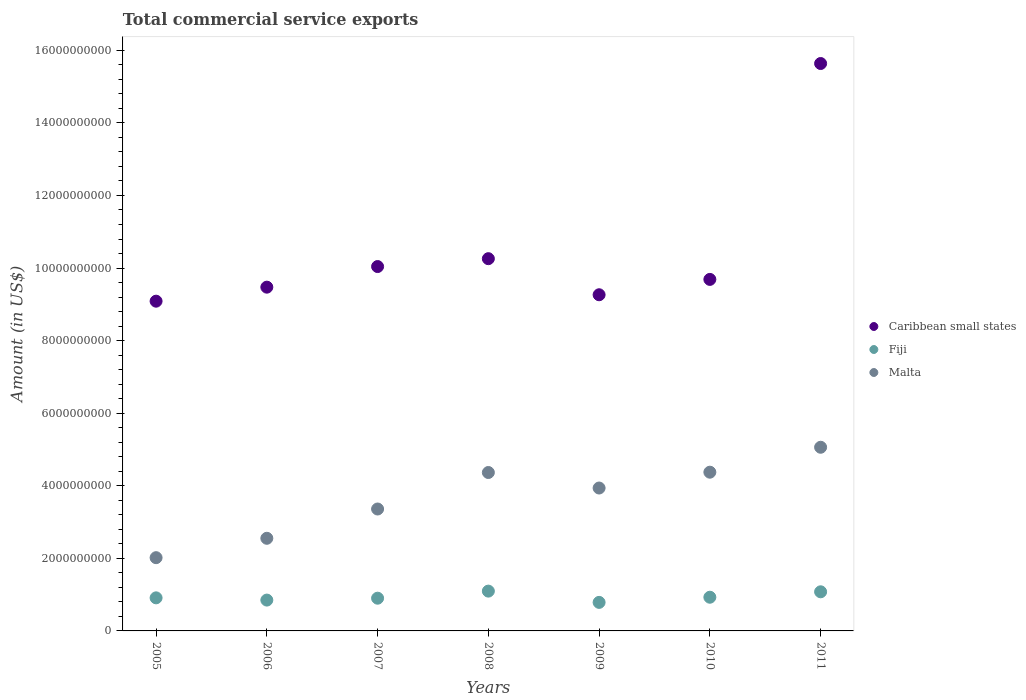What is the total commercial service exports in Caribbean small states in 2008?
Your response must be concise. 1.03e+1. Across all years, what is the maximum total commercial service exports in Caribbean small states?
Provide a succinct answer. 1.56e+1. Across all years, what is the minimum total commercial service exports in Malta?
Keep it short and to the point. 2.02e+09. In which year was the total commercial service exports in Malta maximum?
Provide a short and direct response. 2011. In which year was the total commercial service exports in Malta minimum?
Keep it short and to the point. 2005. What is the total total commercial service exports in Malta in the graph?
Your answer should be compact. 2.57e+1. What is the difference between the total commercial service exports in Caribbean small states in 2008 and that in 2009?
Provide a succinct answer. 9.94e+08. What is the difference between the total commercial service exports in Malta in 2011 and the total commercial service exports in Caribbean small states in 2009?
Your response must be concise. -4.20e+09. What is the average total commercial service exports in Fiji per year?
Ensure brevity in your answer.  9.36e+08. In the year 2008, what is the difference between the total commercial service exports in Malta and total commercial service exports in Fiji?
Give a very brief answer. 3.27e+09. In how many years, is the total commercial service exports in Fiji greater than 12400000000 US$?
Offer a terse response. 0. What is the ratio of the total commercial service exports in Caribbean small states in 2006 to that in 2007?
Your response must be concise. 0.94. Is the total commercial service exports in Caribbean small states in 2006 less than that in 2008?
Your response must be concise. Yes. Is the difference between the total commercial service exports in Malta in 2008 and 2010 greater than the difference between the total commercial service exports in Fiji in 2008 and 2010?
Offer a terse response. No. What is the difference between the highest and the second highest total commercial service exports in Malta?
Your answer should be very brief. 6.87e+08. What is the difference between the highest and the lowest total commercial service exports in Fiji?
Give a very brief answer. 3.11e+08. In how many years, is the total commercial service exports in Caribbean small states greater than the average total commercial service exports in Caribbean small states taken over all years?
Your answer should be compact. 1. Is the sum of the total commercial service exports in Fiji in 2007 and 2008 greater than the maximum total commercial service exports in Caribbean small states across all years?
Your answer should be very brief. No. Is it the case that in every year, the sum of the total commercial service exports in Fiji and total commercial service exports in Caribbean small states  is greater than the total commercial service exports in Malta?
Provide a succinct answer. Yes. Does the total commercial service exports in Fiji monotonically increase over the years?
Your answer should be very brief. No. Is the total commercial service exports in Caribbean small states strictly greater than the total commercial service exports in Fiji over the years?
Make the answer very short. Yes. Are the values on the major ticks of Y-axis written in scientific E-notation?
Offer a terse response. No. Does the graph contain grids?
Make the answer very short. No. Where does the legend appear in the graph?
Ensure brevity in your answer.  Center right. How many legend labels are there?
Make the answer very short. 3. What is the title of the graph?
Give a very brief answer. Total commercial service exports. What is the label or title of the X-axis?
Make the answer very short. Years. What is the label or title of the Y-axis?
Your answer should be compact. Amount (in US$). What is the Amount (in US$) of Caribbean small states in 2005?
Ensure brevity in your answer.  9.09e+09. What is the Amount (in US$) in Fiji in 2005?
Your answer should be very brief. 9.11e+08. What is the Amount (in US$) of Malta in 2005?
Make the answer very short. 2.02e+09. What is the Amount (in US$) of Caribbean small states in 2006?
Offer a very short reply. 9.47e+09. What is the Amount (in US$) of Fiji in 2006?
Your response must be concise. 8.50e+08. What is the Amount (in US$) of Malta in 2006?
Offer a very short reply. 2.55e+09. What is the Amount (in US$) in Caribbean small states in 2007?
Provide a succinct answer. 1.00e+1. What is the Amount (in US$) in Fiji in 2007?
Give a very brief answer. 9.02e+08. What is the Amount (in US$) in Malta in 2007?
Offer a terse response. 3.36e+09. What is the Amount (in US$) in Caribbean small states in 2008?
Ensure brevity in your answer.  1.03e+1. What is the Amount (in US$) in Fiji in 2008?
Make the answer very short. 1.10e+09. What is the Amount (in US$) of Malta in 2008?
Make the answer very short. 4.37e+09. What is the Amount (in US$) of Caribbean small states in 2009?
Make the answer very short. 9.26e+09. What is the Amount (in US$) of Fiji in 2009?
Offer a terse response. 7.86e+08. What is the Amount (in US$) in Malta in 2009?
Keep it short and to the point. 3.94e+09. What is the Amount (in US$) in Caribbean small states in 2010?
Your answer should be compact. 9.69e+09. What is the Amount (in US$) of Fiji in 2010?
Give a very brief answer. 9.28e+08. What is the Amount (in US$) in Malta in 2010?
Make the answer very short. 4.37e+09. What is the Amount (in US$) in Caribbean small states in 2011?
Your answer should be very brief. 1.56e+1. What is the Amount (in US$) of Fiji in 2011?
Offer a terse response. 1.08e+09. What is the Amount (in US$) of Malta in 2011?
Provide a succinct answer. 5.06e+09. Across all years, what is the maximum Amount (in US$) of Caribbean small states?
Provide a short and direct response. 1.56e+1. Across all years, what is the maximum Amount (in US$) in Fiji?
Your response must be concise. 1.10e+09. Across all years, what is the maximum Amount (in US$) in Malta?
Provide a short and direct response. 5.06e+09. Across all years, what is the minimum Amount (in US$) of Caribbean small states?
Provide a succinct answer. 9.09e+09. Across all years, what is the minimum Amount (in US$) in Fiji?
Your response must be concise. 7.86e+08. Across all years, what is the minimum Amount (in US$) of Malta?
Give a very brief answer. 2.02e+09. What is the total Amount (in US$) in Caribbean small states in the graph?
Offer a very short reply. 7.34e+1. What is the total Amount (in US$) in Fiji in the graph?
Keep it short and to the point. 6.55e+09. What is the total Amount (in US$) in Malta in the graph?
Your answer should be compact. 2.57e+1. What is the difference between the Amount (in US$) of Caribbean small states in 2005 and that in 2006?
Your response must be concise. -3.86e+08. What is the difference between the Amount (in US$) of Fiji in 2005 and that in 2006?
Ensure brevity in your answer.  6.16e+07. What is the difference between the Amount (in US$) in Malta in 2005 and that in 2006?
Provide a succinct answer. -5.34e+08. What is the difference between the Amount (in US$) of Caribbean small states in 2005 and that in 2007?
Your answer should be compact. -9.54e+08. What is the difference between the Amount (in US$) of Fiji in 2005 and that in 2007?
Provide a short and direct response. 9.77e+06. What is the difference between the Amount (in US$) of Malta in 2005 and that in 2007?
Keep it short and to the point. -1.34e+09. What is the difference between the Amount (in US$) in Caribbean small states in 2005 and that in 2008?
Ensure brevity in your answer.  -1.17e+09. What is the difference between the Amount (in US$) in Fiji in 2005 and that in 2008?
Give a very brief answer. -1.85e+08. What is the difference between the Amount (in US$) of Malta in 2005 and that in 2008?
Provide a succinct answer. -2.35e+09. What is the difference between the Amount (in US$) in Caribbean small states in 2005 and that in 2009?
Provide a succinct answer. -1.77e+08. What is the difference between the Amount (in US$) in Fiji in 2005 and that in 2009?
Offer a terse response. 1.25e+08. What is the difference between the Amount (in US$) in Malta in 2005 and that in 2009?
Give a very brief answer. -1.92e+09. What is the difference between the Amount (in US$) of Caribbean small states in 2005 and that in 2010?
Offer a very short reply. -6.00e+08. What is the difference between the Amount (in US$) of Fiji in 2005 and that in 2010?
Provide a succinct answer. -1.69e+07. What is the difference between the Amount (in US$) in Malta in 2005 and that in 2010?
Give a very brief answer. -2.36e+09. What is the difference between the Amount (in US$) of Caribbean small states in 2005 and that in 2011?
Offer a terse response. -6.55e+09. What is the difference between the Amount (in US$) of Fiji in 2005 and that in 2011?
Your answer should be compact. -1.66e+08. What is the difference between the Amount (in US$) of Malta in 2005 and that in 2011?
Make the answer very short. -3.04e+09. What is the difference between the Amount (in US$) of Caribbean small states in 2006 and that in 2007?
Ensure brevity in your answer.  -5.68e+08. What is the difference between the Amount (in US$) of Fiji in 2006 and that in 2007?
Provide a short and direct response. -5.18e+07. What is the difference between the Amount (in US$) in Malta in 2006 and that in 2007?
Offer a terse response. -8.07e+08. What is the difference between the Amount (in US$) of Caribbean small states in 2006 and that in 2008?
Ensure brevity in your answer.  -7.85e+08. What is the difference between the Amount (in US$) in Fiji in 2006 and that in 2008?
Your answer should be compact. -2.47e+08. What is the difference between the Amount (in US$) in Malta in 2006 and that in 2008?
Your response must be concise. -1.81e+09. What is the difference between the Amount (in US$) in Caribbean small states in 2006 and that in 2009?
Give a very brief answer. 2.09e+08. What is the difference between the Amount (in US$) of Fiji in 2006 and that in 2009?
Your answer should be compact. 6.36e+07. What is the difference between the Amount (in US$) of Malta in 2006 and that in 2009?
Your answer should be very brief. -1.39e+09. What is the difference between the Amount (in US$) of Caribbean small states in 2006 and that in 2010?
Your answer should be very brief. -2.14e+08. What is the difference between the Amount (in US$) of Fiji in 2006 and that in 2010?
Make the answer very short. -7.85e+07. What is the difference between the Amount (in US$) in Malta in 2006 and that in 2010?
Your answer should be compact. -1.82e+09. What is the difference between the Amount (in US$) in Caribbean small states in 2006 and that in 2011?
Give a very brief answer. -6.16e+09. What is the difference between the Amount (in US$) of Fiji in 2006 and that in 2011?
Your response must be concise. -2.28e+08. What is the difference between the Amount (in US$) in Malta in 2006 and that in 2011?
Offer a very short reply. -2.51e+09. What is the difference between the Amount (in US$) of Caribbean small states in 2007 and that in 2008?
Your response must be concise. -2.17e+08. What is the difference between the Amount (in US$) of Fiji in 2007 and that in 2008?
Provide a succinct answer. -1.95e+08. What is the difference between the Amount (in US$) of Malta in 2007 and that in 2008?
Your answer should be very brief. -1.01e+09. What is the difference between the Amount (in US$) in Caribbean small states in 2007 and that in 2009?
Provide a succinct answer. 7.77e+08. What is the difference between the Amount (in US$) of Fiji in 2007 and that in 2009?
Offer a terse response. 1.15e+08. What is the difference between the Amount (in US$) in Malta in 2007 and that in 2009?
Keep it short and to the point. -5.78e+08. What is the difference between the Amount (in US$) of Caribbean small states in 2007 and that in 2010?
Your answer should be very brief. 3.54e+08. What is the difference between the Amount (in US$) in Fiji in 2007 and that in 2010?
Your answer should be very brief. -2.67e+07. What is the difference between the Amount (in US$) in Malta in 2007 and that in 2010?
Your response must be concise. -1.01e+09. What is the difference between the Amount (in US$) of Caribbean small states in 2007 and that in 2011?
Offer a very short reply. -5.60e+09. What is the difference between the Amount (in US$) of Fiji in 2007 and that in 2011?
Offer a very short reply. -1.76e+08. What is the difference between the Amount (in US$) of Malta in 2007 and that in 2011?
Make the answer very short. -1.70e+09. What is the difference between the Amount (in US$) in Caribbean small states in 2008 and that in 2009?
Offer a very short reply. 9.94e+08. What is the difference between the Amount (in US$) of Fiji in 2008 and that in 2009?
Provide a short and direct response. 3.11e+08. What is the difference between the Amount (in US$) of Malta in 2008 and that in 2009?
Provide a succinct answer. 4.28e+08. What is the difference between the Amount (in US$) of Caribbean small states in 2008 and that in 2010?
Your answer should be very brief. 5.71e+08. What is the difference between the Amount (in US$) in Fiji in 2008 and that in 2010?
Your answer should be very brief. 1.68e+08. What is the difference between the Amount (in US$) in Malta in 2008 and that in 2010?
Your answer should be very brief. -8.65e+06. What is the difference between the Amount (in US$) in Caribbean small states in 2008 and that in 2011?
Keep it short and to the point. -5.38e+09. What is the difference between the Amount (in US$) of Fiji in 2008 and that in 2011?
Your answer should be very brief. 1.89e+07. What is the difference between the Amount (in US$) in Malta in 2008 and that in 2011?
Your answer should be compact. -6.96e+08. What is the difference between the Amount (in US$) in Caribbean small states in 2009 and that in 2010?
Your answer should be very brief. -4.23e+08. What is the difference between the Amount (in US$) of Fiji in 2009 and that in 2010?
Provide a short and direct response. -1.42e+08. What is the difference between the Amount (in US$) in Malta in 2009 and that in 2010?
Make the answer very short. -4.36e+08. What is the difference between the Amount (in US$) in Caribbean small states in 2009 and that in 2011?
Make the answer very short. -6.37e+09. What is the difference between the Amount (in US$) in Fiji in 2009 and that in 2011?
Offer a very short reply. -2.92e+08. What is the difference between the Amount (in US$) in Malta in 2009 and that in 2011?
Give a very brief answer. -1.12e+09. What is the difference between the Amount (in US$) in Caribbean small states in 2010 and that in 2011?
Provide a succinct answer. -5.95e+09. What is the difference between the Amount (in US$) of Fiji in 2010 and that in 2011?
Make the answer very short. -1.50e+08. What is the difference between the Amount (in US$) of Malta in 2010 and that in 2011?
Provide a short and direct response. -6.87e+08. What is the difference between the Amount (in US$) of Caribbean small states in 2005 and the Amount (in US$) of Fiji in 2006?
Offer a terse response. 8.24e+09. What is the difference between the Amount (in US$) in Caribbean small states in 2005 and the Amount (in US$) in Malta in 2006?
Your answer should be compact. 6.53e+09. What is the difference between the Amount (in US$) of Fiji in 2005 and the Amount (in US$) of Malta in 2006?
Give a very brief answer. -1.64e+09. What is the difference between the Amount (in US$) in Caribbean small states in 2005 and the Amount (in US$) in Fiji in 2007?
Your answer should be very brief. 8.19e+09. What is the difference between the Amount (in US$) in Caribbean small states in 2005 and the Amount (in US$) in Malta in 2007?
Make the answer very short. 5.73e+09. What is the difference between the Amount (in US$) in Fiji in 2005 and the Amount (in US$) in Malta in 2007?
Offer a terse response. -2.45e+09. What is the difference between the Amount (in US$) of Caribbean small states in 2005 and the Amount (in US$) of Fiji in 2008?
Offer a very short reply. 7.99e+09. What is the difference between the Amount (in US$) of Caribbean small states in 2005 and the Amount (in US$) of Malta in 2008?
Offer a terse response. 4.72e+09. What is the difference between the Amount (in US$) in Fiji in 2005 and the Amount (in US$) in Malta in 2008?
Your answer should be compact. -3.45e+09. What is the difference between the Amount (in US$) in Caribbean small states in 2005 and the Amount (in US$) in Fiji in 2009?
Provide a short and direct response. 8.30e+09. What is the difference between the Amount (in US$) of Caribbean small states in 2005 and the Amount (in US$) of Malta in 2009?
Keep it short and to the point. 5.15e+09. What is the difference between the Amount (in US$) in Fiji in 2005 and the Amount (in US$) in Malta in 2009?
Make the answer very short. -3.03e+09. What is the difference between the Amount (in US$) in Caribbean small states in 2005 and the Amount (in US$) in Fiji in 2010?
Ensure brevity in your answer.  8.16e+09. What is the difference between the Amount (in US$) in Caribbean small states in 2005 and the Amount (in US$) in Malta in 2010?
Make the answer very short. 4.71e+09. What is the difference between the Amount (in US$) in Fiji in 2005 and the Amount (in US$) in Malta in 2010?
Keep it short and to the point. -3.46e+09. What is the difference between the Amount (in US$) of Caribbean small states in 2005 and the Amount (in US$) of Fiji in 2011?
Your response must be concise. 8.01e+09. What is the difference between the Amount (in US$) in Caribbean small states in 2005 and the Amount (in US$) in Malta in 2011?
Ensure brevity in your answer.  4.03e+09. What is the difference between the Amount (in US$) in Fiji in 2005 and the Amount (in US$) in Malta in 2011?
Provide a succinct answer. -4.15e+09. What is the difference between the Amount (in US$) of Caribbean small states in 2006 and the Amount (in US$) of Fiji in 2007?
Your response must be concise. 8.57e+09. What is the difference between the Amount (in US$) in Caribbean small states in 2006 and the Amount (in US$) in Malta in 2007?
Your response must be concise. 6.11e+09. What is the difference between the Amount (in US$) of Fiji in 2006 and the Amount (in US$) of Malta in 2007?
Provide a short and direct response. -2.51e+09. What is the difference between the Amount (in US$) in Caribbean small states in 2006 and the Amount (in US$) in Fiji in 2008?
Provide a short and direct response. 8.38e+09. What is the difference between the Amount (in US$) in Caribbean small states in 2006 and the Amount (in US$) in Malta in 2008?
Make the answer very short. 5.11e+09. What is the difference between the Amount (in US$) in Fiji in 2006 and the Amount (in US$) in Malta in 2008?
Give a very brief answer. -3.52e+09. What is the difference between the Amount (in US$) in Caribbean small states in 2006 and the Amount (in US$) in Fiji in 2009?
Make the answer very short. 8.69e+09. What is the difference between the Amount (in US$) in Caribbean small states in 2006 and the Amount (in US$) in Malta in 2009?
Keep it short and to the point. 5.54e+09. What is the difference between the Amount (in US$) in Fiji in 2006 and the Amount (in US$) in Malta in 2009?
Your response must be concise. -3.09e+09. What is the difference between the Amount (in US$) in Caribbean small states in 2006 and the Amount (in US$) in Fiji in 2010?
Offer a very short reply. 8.54e+09. What is the difference between the Amount (in US$) in Caribbean small states in 2006 and the Amount (in US$) in Malta in 2010?
Offer a very short reply. 5.10e+09. What is the difference between the Amount (in US$) of Fiji in 2006 and the Amount (in US$) of Malta in 2010?
Offer a very short reply. -3.52e+09. What is the difference between the Amount (in US$) in Caribbean small states in 2006 and the Amount (in US$) in Fiji in 2011?
Your response must be concise. 8.40e+09. What is the difference between the Amount (in US$) in Caribbean small states in 2006 and the Amount (in US$) in Malta in 2011?
Your answer should be very brief. 4.41e+09. What is the difference between the Amount (in US$) in Fiji in 2006 and the Amount (in US$) in Malta in 2011?
Your answer should be very brief. -4.21e+09. What is the difference between the Amount (in US$) of Caribbean small states in 2007 and the Amount (in US$) of Fiji in 2008?
Provide a short and direct response. 8.94e+09. What is the difference between the Amount (in US$) of Caribbean small states in 2007 and the Amount (in US$) of Malta in 2008?
Keep it short and to the point. 5.68e+09. What is the difference between the Amount (in US$) of Fiji in 2007 and the Amount (in US$) of Malta in 2008?
Offer a terse response. -3.46e+09. What is the difference between the Amount (in US$) of Caribbean small states in 2007 and the Amount (in US$) of Fiji in 2009?
Keep it short and to the point. 9.25e+09. What is the difference between the Amount (in US$) in Caribbean small states in 2007 and the Amount (in US$) in Malta in 2009?
Give a very brief answer. 6.10e+09. What is the difference between the Amount (in US$) in Fiji in 2007 and the Amount (in US$) in Malta in 2009?
Your answer should be very brief. -3.04e+09. What is the difference between the Amount (in US$) in Caribbean small states in 2007 and the Amount (in US$) in Fiji in 2010?
Your answer should be very brief. 9.11e+09. What is the difference between the Amount (in US$) of Caribbean small states in 2007 and the Amount (in US$) of Malta in 2010?
Offer a very short reply. 5.67e+09. What is the difference between the Amount (in US$) of Fiji in 2007 and the Amount (in US$) of Malta in 2010?
Offer a very short reply. -3.47e+09. What is the difference between the Amount (in US$) in Caribbean small states in 2007 and the Amount (in US$) in Fiji in 2011?
Your answer should be very brief. 8.96e+09. What is the difference between the Amount (in US$) in Caribbean small states in 2007 and the Amount (in US$) in Malta in 2011?
Offer a terse response. 4.98e+09. What is the difference between the Amount (in US$) of Fiji in 2007 and the Amount (in US$) of Malta in 2011?
Your response must be concise. -4.16e+09. What is the difference between the Amount (in US$) in Caribbean small states in 2008 and the Amount (in US$) in Fiji in 2009?
Provide a succinct answer. 9.47e+09. What is the difference between the Amount (in US$) in Caribbean small states in 2008 and the Amount (in US$) in Malta in 2009?
Offer a terse response. 6.32e+09. What is the difference between the Amount (in US$) in Fiji in 2008 and the Amount (in US$) in Malta in 2009?
Offer a terse response. -2.84e+09. What is the difference between the Amount (in US$) of Caribbean small states in 2008 and the Amount (in US$) of Fiji in 2010?
Provide a succinct answer. 9.33e+09. What is the difference between the Amount (in US$) of Caribbean small states in 2008 and the Amount (in US$) of Malta in 2010?
Keep it short and to the point. 5.88e+09. What is the difference between the Amount (in US$) in Fiji in 2008 and the Amount (in US$) in Malta in 2010?
Keep it short and to the point. -3.28e+09. What is the difference between the Amount (in US$) of Caribbean small states in 2008 and the Amount (in US$) of Fiji in 2011?
Keep it short and to the point. 9.18e+09. What is the difference between the Amount (in US$) of Caribbean small states in 2008 and the Amount (in US$) of Malta in 2011?
Make the answer very short. 5.20e+09. What is the difference between the Amount (in US$) in Fiji in 2008 and the Amount (in US$) in Malta in 2011?
Make the answer very short. -3.96e+09. What is the difference between the Amount (in US$) in Caribbean small states in 2009 and the Amount (in US$) in Fiji in 2010?
Ensure brevity in your answer.  8.34e+09. What is the difference between the Amount (in US$) of Caribbean small states in 2009 and the Amount (in US$) of Malta in 2010?
Offer a terse response. 4.89e+09. What is the difference between the Amount (in US$) of Fiji in 2009 and the Amount (in US$) of Malta in 2010?
Give a very brief answer. -3.59e+09. What is the difference between the Amount (in US$) in Caribbean small states in 2009 and the Amount (in US$) in Fiji in 2011?
Provide a short and direct response. 8.19e+09. What is the difference between the Amount (in US$) of Caribbean small states in 2009 and the Amount (in US$) of Malta in 2011?
Give a very brief answer. 4.20e+09. What is the difference between the Amount (in US$) of Fiji in 2009 and the Amount (in US$) of Malta in 2011?
Your answer should be very brief. -4.27e+09. What is the difference between the Amount (in US$) in Caribbean small states in 2010 and the Amount (in US$) in Fiji in 2011?
Your answer should be very brief. 8.61e+09. What is the difference between the Amount (in US$) of Caribbean small states in 2010 and the Amount (in US$) of Malta in 2011?
Keep it short and to the point. 4.63e+09. What is the difference between the Amount (in US$) of Fiji in 2010 and the Amount (in US$) of Malta in 2011?
Ensure brevity in your answer.  -4.13e+09. What is the average Amount (in US$) of Caribbean small states per year?
Your response must be concise. 1.05e+1. What is the average Amount (in US$) of Fiji per year?
Make the answer very short. 9.36e+08. What is the average Amount (in US$) of Malta per year?
Ensure brevity in your answer.  3.67e+09. In the year 2005, what is the difference between the Amount (in US$) of Caribbean small states and Amount (in US$) of Fiji?
Give a very brief answer. 8.18e+09. In the year 2005, what is the difference between the Amount (in US$) of Caribbean small states and Amount (in US$) of Malta?
Make the answer very short. 7.07e+09. In the year 2005, what is the difference between the Amount (in US$) in Fiji and Amount (in US$) in Malta?
Make the answer very short. -1.11e+09. In the year 2006, what is the difference between the Amount (in US$) in Caribbean small states and Amount (in US$) in Fiji?
Provide a short and direct response. 8.62e+09. In the year 2006, what is the difference between the Amount (in US$) in Caribbean small states and Amount (in US$) in Malta?
Provide a short and direct response. 6.92e+09. In the year 2006, what is the difference between the Amount (in US$) of Fiji and Amount (in US$) of Malta?
Your response must be concise. -1.70e+09. In the year 2007, what is the difference between the Amount (in US$) in Caribbean small states and Amount (in US$) in Fiji?
Offer a very short reply. 9.14e+09. In the year 2007, what is the difference between the Amount (in US$) in Caribbean small states and Amount (in US$) in Malta?
Make the answer very short. 6.68e+09. In the year 2007, what is the difference between the Amount (in US$) of Fiji and Amount (in US$) of Malta?
Offer a terse response. -2.46e+09. In the year 2008, what is the difference between the Amount (in US$) of Caribbean small states and Amount (in US$) of Fiji?
Keep it short and to the point. 9.16e+09. In the year 2008, what is the difference between the Amount (in US$) in Caribbean small states and Amount (in US$) in Malta?
Give a very brief answer. 5.89e+09. In the year 2008, what is the difference between the Amount (in US$) in Fiji and Amount (in US$) in Malta?
Offer a very short reply. -3.27e+09. In the year 2009, what is the difference between the Amount (in US$) in Caribbean small states and Amount (in US$) in Fiji?
Keep it short and to the point. 8.48e+09. In the year 2009, what is the difference between the Amount (in US$) of Caribbean small states and Amount (in US$) of Malta?
Provide a short and direct response. 5.33e+09. In the year 2009, what is the difference between the Amount (in US$) of Fiji and Amount (in US$) of Malta?
Offer a very short reply. -3.15e+09. In the year 2010, what is the difference between the Amount (in US$) of Caribbean small states and Amount (in US$) of Fiji?
Offer a very short reply. 8.76e+09. In the year 2010, what is the difference between the Amount (in US$) of Caribbean small states and Amount (in US$) of Malta?
Offer a very short reply. 5.31e+09. In the year 2010, what is the difference between the Amount (in US$) in Fiji and Amount (in US$) in Malta?
Ensure brevity in your answer.  -3.45e+09. In the year 2011, what is the difference between the Amount (in US$) in Caribbean small states and Amount (in US$) in Fiji?
Your answer should be compact. 1.46e+1. In the year 2011, what is the difference between the Amount (in US$) in Caribbean small states and Amount (in US$) in Malta?
Offer a terse response. 1.06e+1. In the year 2011, what is the difference between the Amount (in US$) of Fiji and Amount (in US$) of Malta?
Provide a succinct answer. -3.98e+09. What is the ratio of the Amount (in US$) in Caribbean small states in 2005 to that in 2006?
Your answer should be compact. 0.96. What is the ratio of the Amount (in US$) of Fiji in 2005 to that in 2006?
Your response must be concise. 1.07. What is the ratio of the Amount (in US$) in Malta in 2005 to that in 2006?
Provide a succinct answer. 0.79. What is the ratio of the Amount (in US$) of Caribbean small states in 2005 to that in 2007?
Keep it short and to the point. 0.91. What is the ratio of the Amount (in US$) of Fiji in 2005 to that in 2007?
Make the answer very short. 1.01. What is the ratio of the Amount (in US$) of Malta in 2005 to that in 2007?
Give a very brief answer. 0.6. What is the ratio of the Amount (in US$) in Caribbean small states in 2005 to that in 2008?
Keep it short and to the point. 0.89. What is the ratio of the Amount (in US$) of Fiji in 2005 to that in 2008?
Your answer should be very brief. 0.83. What is the ratio of the Amount (in US$) of Malta in 2005 to that in 2008?
Keep it short and to the point. 0.46. What is the ratio of the Amount (in US$) in Caribbean small states in 2005 to that in 2009?
Give a very brief answer. 0.98. What is the ratio of the Amount (in US$) of Fiji in 2005 to that in 2009?
Your answer should be very brief. 1.16. What is the ratio of the Amount (in US$) of Malta in 2005 to that in 2009?
Make the answer very short. 0.51. What is the ratio of the Amount (in US$) of Caribbean small states in 2005 to that in 2010?
Offer a very short reply. 0.94. What is the ratio of the Amount (in US$) in Fiji in 2005 to that in 2010?
Ensure brevity in your answer.  0.98. What is the ratio of the Amount (in US$) in Malta in 2005 to that in 2010?
Make the answer very short. 0.46. What is the ratio of the Amount (in US$) in Caribbean small states in 2005 to that in 2011?
Your answer should be compact. 0.58. What is the ratio of the Amount (in US$) of Fiji in 2005 to that in 2011?
Your answer should be compact. 0.85. What is the ratio of the Amount (in US$) of Malta in 2005 to that in 2011?
Provide a succinct answer. 0.4. What is the ratio of the Amount (in US$) of Caribbean small states in 2006 to that in 2007?
Give a very brief answer. 0.94. What is the ratio of the Amount (in US$) in Fiji in 2006 to that in 2007?
Provide a succinct answer. 0.94. What is the ratio of the Amount (in US$) of Malta in 2006 to that in 2007?
Your response must be concise. 0.76. What is the ratio of the Amount (in US$) of Caribbean small states in 2006 to that in 2008?
Provide a succinct answer. 0.92. What is the ratio of the Amount (in US$) of Fiji in 2006 to that in 2008?
Keep it short and to the point. 0.77. What is the ratio of the Amount (in US$) in Malta in 2006 to that in 2008?
Keep it short and to the point. 0.58. What is the ratio of the Amount (in US$) of Caribbean small states in 2006 to that in 2009?
Provide a short and direct response. 1.02. What is the ratio of the Amount (in US$) of Fiji in 2006 to that in 2009?
Make the answer very short. 1.08. What is the ratio of the Amount (in US$) of Malta in 2006 to that in 2009?
Provide a short and direct response. 0.65. What is the ratio of the Amount (in US$) in Caribbean small states in 2006 to that in 2010?
Ensure brevity in your answer.  0.98. What is the ratio of the Amount (in US$) in Fiji in 2006 to that in 2010?
Make the answer very short. 0.92. What is the ratio of the Amount (in US$) of Malta in 2006 to that in 2010?
Offer a very short reply. 0.58. What is the ratio of the Amount (in US$) of Caribbean small states in 2006 to that in 2011?
Give a very brief answer. 0.61. What is the ratio of the Amount (in US$) of Fiji in 2006 to that in 2011?
Your answer should be very brief. 0.79. What is the ratio of the Amount (in US$) in Malta in 2006 to that in 2011?
Your answer should be compact. 0.5. What is the ratio of the Amount (in US$) of Caribbean small states in 2007 to that in 2008?
Provide a succinct answer. 0.98. What is the ratio of the Amount (in US$) of Fiji in 2007 to that in 2008?
Your answer should be very brief. 0.82. What is the ratio of the Amount (in US$) in Malta in 2007 to that in 2008?
Make the answer very short. 0.77. What is the ratio of the Amount (in US$) of Caribbean small states in 2007 to that in 2009?
Provide a short and direct response. 1.08. What is the ratio of the Amount (in US$) of Fiji in 2007 to that in 2009?
Your answer should be very brief. 1.15. What is the ratio of the Amount (in US$) in Malta in 2007 to that in 2009?
Your response must be concise. 0.85. What is the ratio of the Amount (in US$) of Caribbean small states in 2007 to that in 2010?
Offer a very short reply. 1.04. What is the ratio of the Amount (in US$) in Fiji in 2007 to that in 2010?
Ensure brevity in your answer.  0.97. What is the ratio of the Amount (in US$) in Malta in 2007 to that in 2010?
Offer a terse response. 0.77. What is the ratio of the Amount (in US$) of Caribbean small states in 2007 to that in 2011?
Offer a terse response. 0.64. What is the ratio of the Amount (in US$) in Fiji in 2007 to that in 2011?
Make the answer very short. 0.84. What is the ratio of the Amount (in US$) of Malta in 2007 to that in 2011?
Your response must be concise. 0.66. What is the ratio of the Amount (in US$) in Caribbean small states in 2008 to that in 2009?
Give a very brief answer. 1.11. What is the ratio of the Amount (in US$) of Fiji in 2008 to that in 2009?
Offer a very short reply. 1.39. What is the ratio of the Amount (in US$) in Malta in 2008 to that in 2009?
Provide a succinct answer. 1.11. What is the ratio of the Amount (in US$) in Caribbean small states in 2008 to that in 2010?
Your response must be concise. 1.06. What is the ratio of the Amount (in US$) of Fiji in 2008 to that in 2010?
Ensure brevity in your answer.  1.18. What is the ratio of the Amount (in US$) in Malta in 2008 to that in 2010?
Keep it short and to the point. 1. What is the ratio of the Amount (in US$) in Caribbean small states in 2008 to that in 2011?
Make the answer very short. 0.66. What is the ratio of the Amount (in US$) in Fiji in 2008 to that in 2011?
Make the answer very short. 1.02. What is the ratio of the Amount (in US$) in Malta in 2008 to that in 2011?
Make the answer very short. 0.86. What is the ratio of the Amount (in US$) of Caribbean small states in 2009 to that in 2010?
Ensure brevity in your answer.  0.96. What is the ratio of the Amount (in US$) of Fiji in 2009 to that in 2010?
Keep it short and to the point. 0.85. What is the ratio of the Amount (in US$) of Malta in 2009 to that in 2010?
Provide a succinct answer. 0.9. What is the ratio of the Amount (in US$) in Caribbean small states in 2009 to that in 2011?
Your answer should be very brief. 0.59. What is the ratio of the Amount (in US$) in Fiji in 2009 to that in 2011?
Your answer should be very brief. 0.73. What is the ratio of the Amount (in US$) in Malta in 2009 to that in 2011?
Give a very brief answer. 0.78. What is the ratio of the Amount (in US$) of Caribbean small states in 2010 to that in 2011?
Provide a succinct answer. 0.62. What is the ratio of the Amount (in US$) in Fiji in 2010 to that in 2011?
Ensure brevity in your answer.  0.86. What is the ratio of the Amount (in US$) in Malta in 2010 to that in 2011?
Make the answer very short. 0.86. What is the difference between the highest and the second highest Amount (in US$) of Caribbean small states?
Provide a succinct answer. 5.38e+09. What is the difference between the highest and the second highest Amount (in US$) in Fiji?
Make the answer very short. 1.89e+07. What is the difference between the highest and the second highest Amount (in US$) of Malta?
Your answer should be very brief. 6.87e+08. What is the difference between the highest and the lowest Amount (in US$) of Caribbean small states?
Your answer should be very brief. 6.55e+09. What is the difference between the highest and the lowest Amount (in US$) in Fiji?
Your answer should be compact. 3.11e+08. What is the difference between the highest and the lowest Amount (in US$) of Malta?
Your answer should be compact. 3.04e+09. 